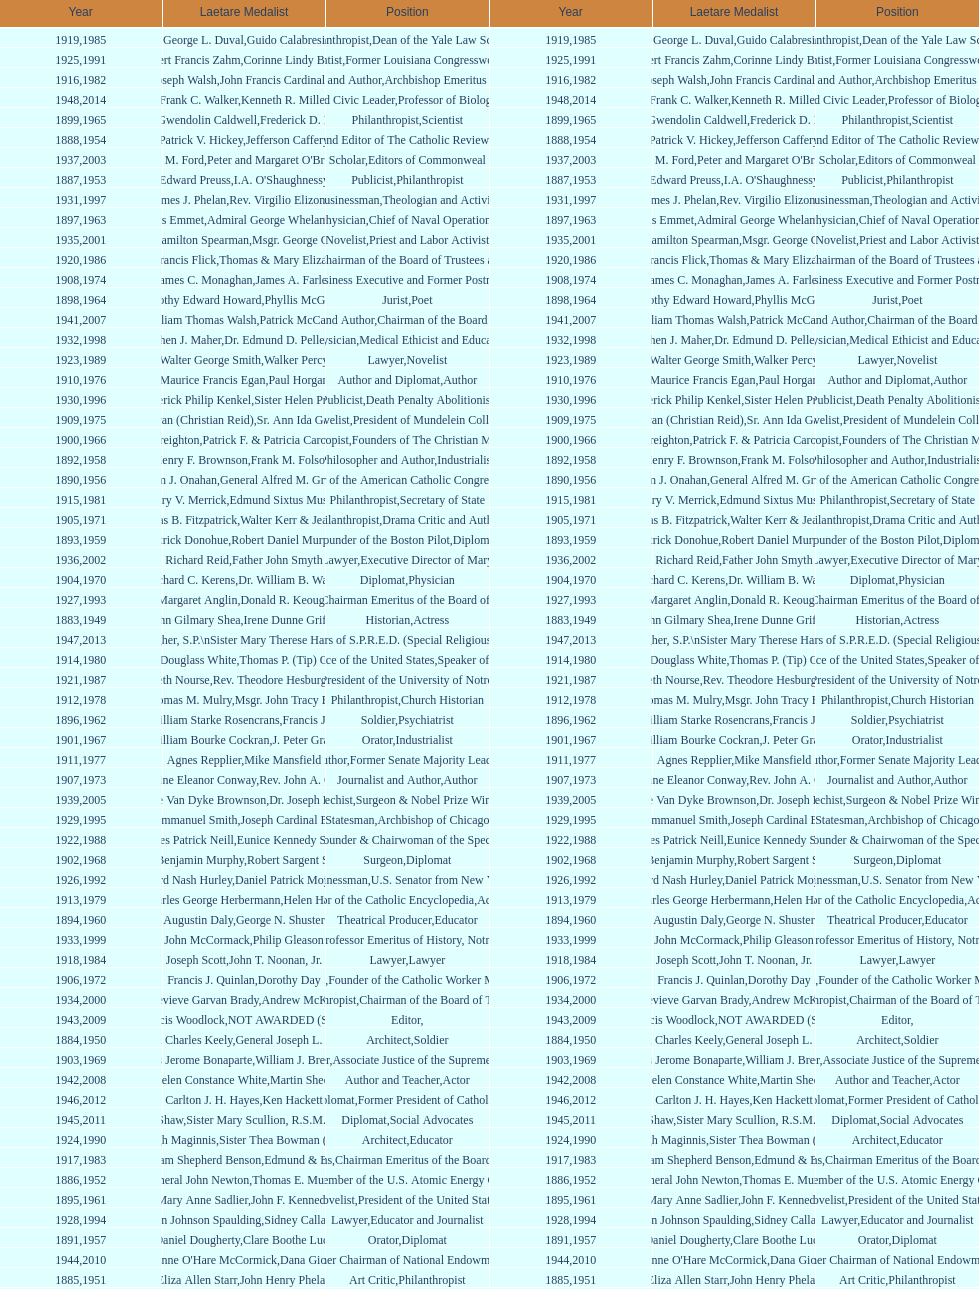What is the name of the laetare medalist listed before edward preuss? General John Newton. 